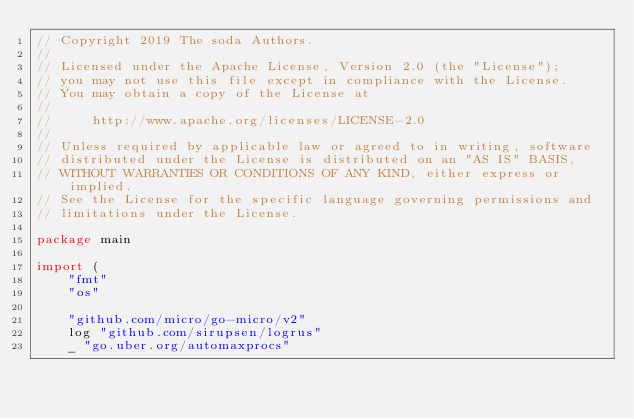Convert code to text. <code><loc_0><loc_0><loc_500><loc_500><_Go_>// Copyright 2019 The soda Authors.
//
// Licensed under the Apache License, Version 2.0 (the "License");
// you may not use this file except in compliance with the License.
// You may obtain a copy of the License at
//
//     http://www.apache.org/licenses/LICENSE-2.0
//
// Unless required by applicable law or agreed to in writing, software
// distributed under the License is distributed on an "AS IS" BASIS,
// WITHOUT WARRANTIES OR CONDITIONS OF ANY KIND, either express or implied.
// See the License for the specific language governing permissions and
// limitations under the License.

package main

import (
	"fmt"
	"os"

	"github.com/micro/go-micro/v2"
	log "github.com/sirupsen/logrus"
	_ "go.uber.org/automaxprocs"
</code> 